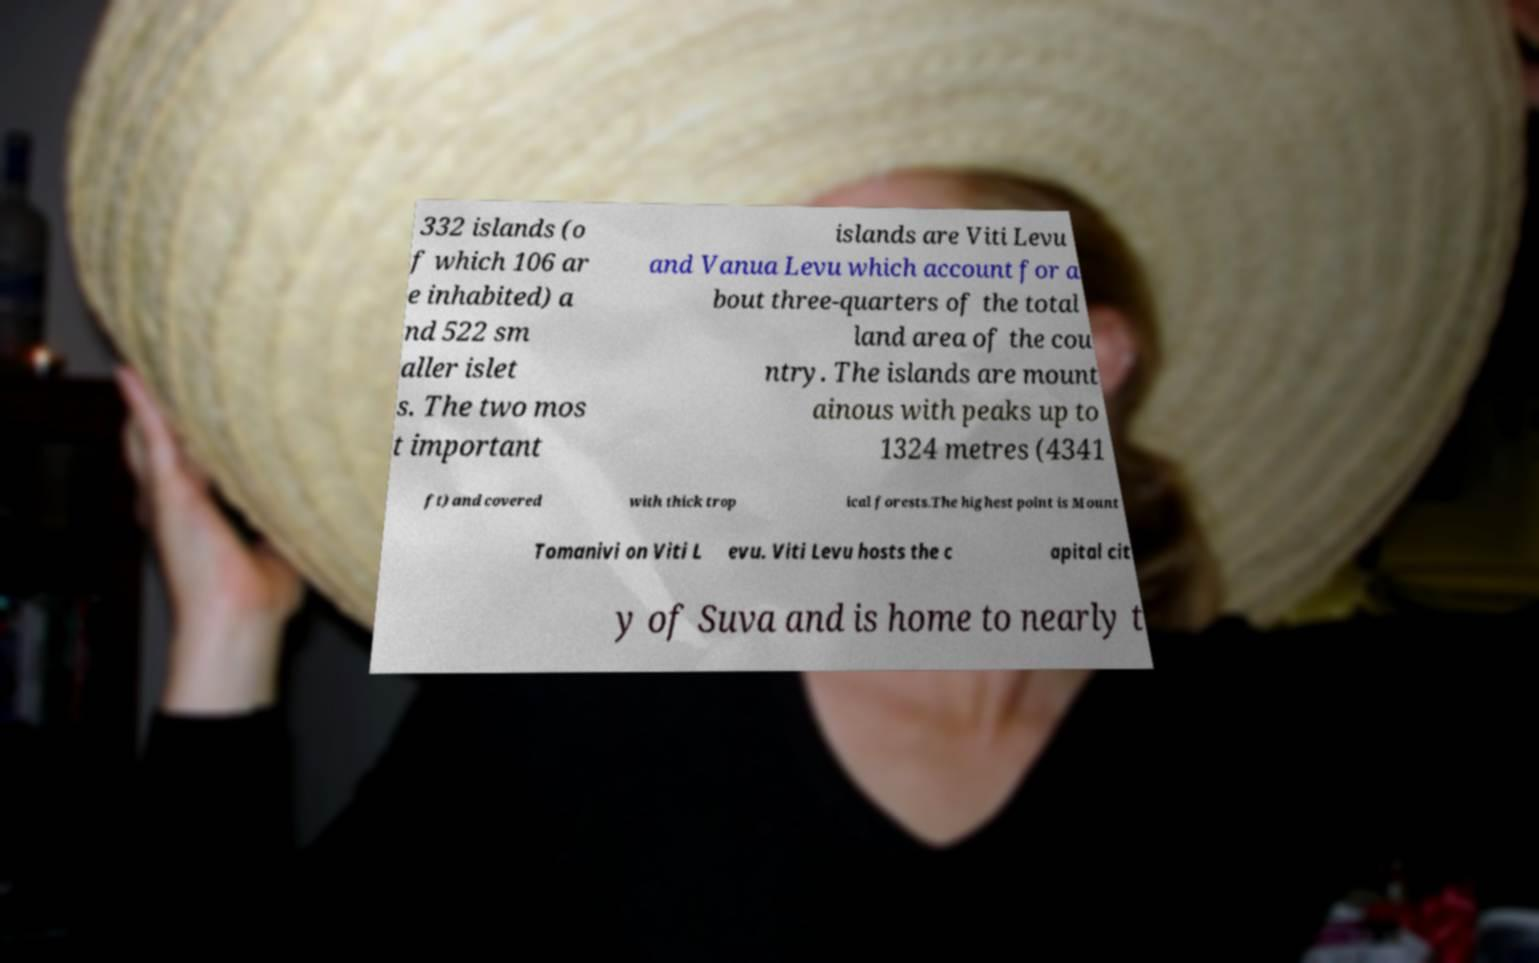For documentation purposes, I need the text within this image transcribed. Could you provide that? 332 islands (o f which 106 ar e inhabited) a nd 522 sm aller islet s. The two mos t important islands are Viti Levu and Vanua Levu which account for a bout three-quarters of the total land area of the cou ntry. The islands are mount ainous with peaks up to 1324 metres (4341 ft) and covered with thick trop ical forests.The highest point is Mount Tomanivi on Viti L evu. Viti Levu hosts the c apital cit y of Suva and is home to nearly t 